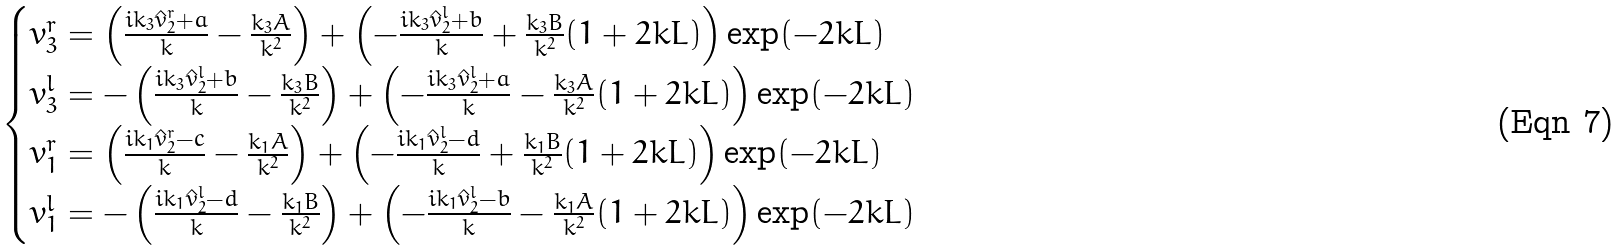Convert formula to latex. <formula><loc_0><loc_0><loc_500><loc_500>\begin{cases} v _ { 3 } ^ { r } = \left ( \frac { i k _ { 3 } \hat { v } _ { 2 } ^ { r } + a } { k } - \frac { k _ { 3 } A } { k ^ { 2 } } \right ) + \left ( - \frac { i k _ { 3 } \hat { v } _ { 2 } ^ { l } + b } { k } + \frac { k _ { 3 } B } { k ^ { 2 } } ( 1 + 2 k L ) \right ) \exp ( - 2 k L ) \\ v _ { 3 } ^ { l } = - \left ( \frac { i k _ { 3 } \hat { v } _ { 2 } ^ { l } + b } { k } - \frac { k _ { 3 } B } { k ^ { 2 } } \right ) + \left ( - \frac { i k _ { 3 } \hat { v } _ { 2 } ^ { l } + a } { k } - \frac { k _ { 3 } A } { k ^ { 2 } } ( 1 + 2 k L ) \right ) \exp ( - 2 k L ) \\ v _ { 1 } ^ { r } = \left ( \frac { i k _ { 1 } \hat { v } _ { 2 } ^ { r } - c } { k } - \frac { k _ { 1 } A } { k ^ { 2 } } \right ) + \left ( - \frac { i k _ { 1 } \hat { v } _ { 2 } ^ { l } - d } { k } + \frac { k _ { 1 } B } { k ^ { 2 } } ( 1 + 2 k L ) \right ) \exp ( - 2 k L ) \\ v _ { 1 } ^ { l } = - \left ( \frac { i k _ { 1 } \hat { v } _ { 2 } ^ { l } - d } { k } - \frac { k _ { 1 } B } { k ^ { 2 } } \right ) + \left ( - \frac { i k _ { 1 } \hat { v } _ { 2 } ^ { l } - b } { k } - \frac { k _ { 1 } A } { k ^ { 2 } } ( 1 + 2 k L ) \right ) \exp ( - 2 k L ) \\ \end{cases}</formula> 